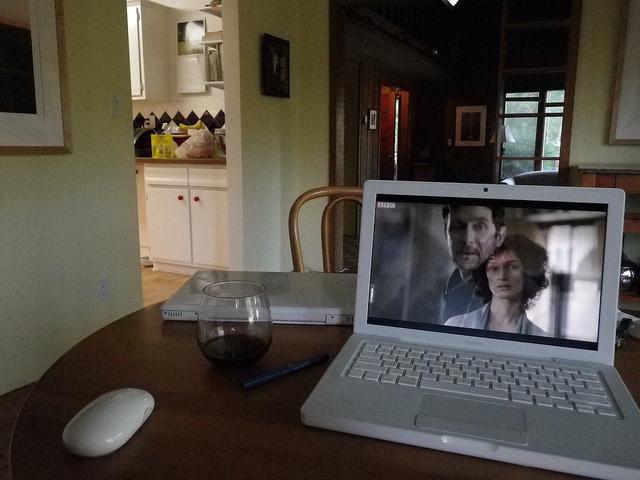What is it sitting on top of?
Quick response, please. Table. Where are the glasses?
Short answer required. Nowhere. What brand is the closed laptop?
Write a very short answer. Apple. What material is the mug made of?
Write a very short answer. Glass. What color are the cabinets?
Write a very short answer. White. Is the device a laptop or a notebook?
Write a very short answer. Laptop. Is the mouse wired or wireless?
Answer briefly. Wireless. Is it daytime?
Concise answer only. Yes. Is the desk and the wall a near-perfect color match?
Be succinct. No. Are there flowers on the table?
Write a very short answer. No. Is this like a corner of a student dorm room?
Short answer required. No. Where is the keyboard?
Answer briefly. Laptop. Which celebrity do you see?
Answer briefly. Sigourney weaver. Is there a light on in another room?
Write a very short answer. Yes. Is the cup upside down?
Be succinct. No. Is there more than one laptop?
Short answer required. Yes. What is to the right of the mouse?
Give a very brief answer. Laptop. What type of glass in sitting on the table?
Be succinct. Wine. Is this a new model?
Keep it brief. No. What is the purpose of these items?
Give a very brief answer. Entertainment. What is inside of the cup?
Give a very brief answer. Wine. Is the laptop being used to watch a movie?
Short answer required. Yes. Are the rooms pictured the same room?
Give a very brief answer. No. 